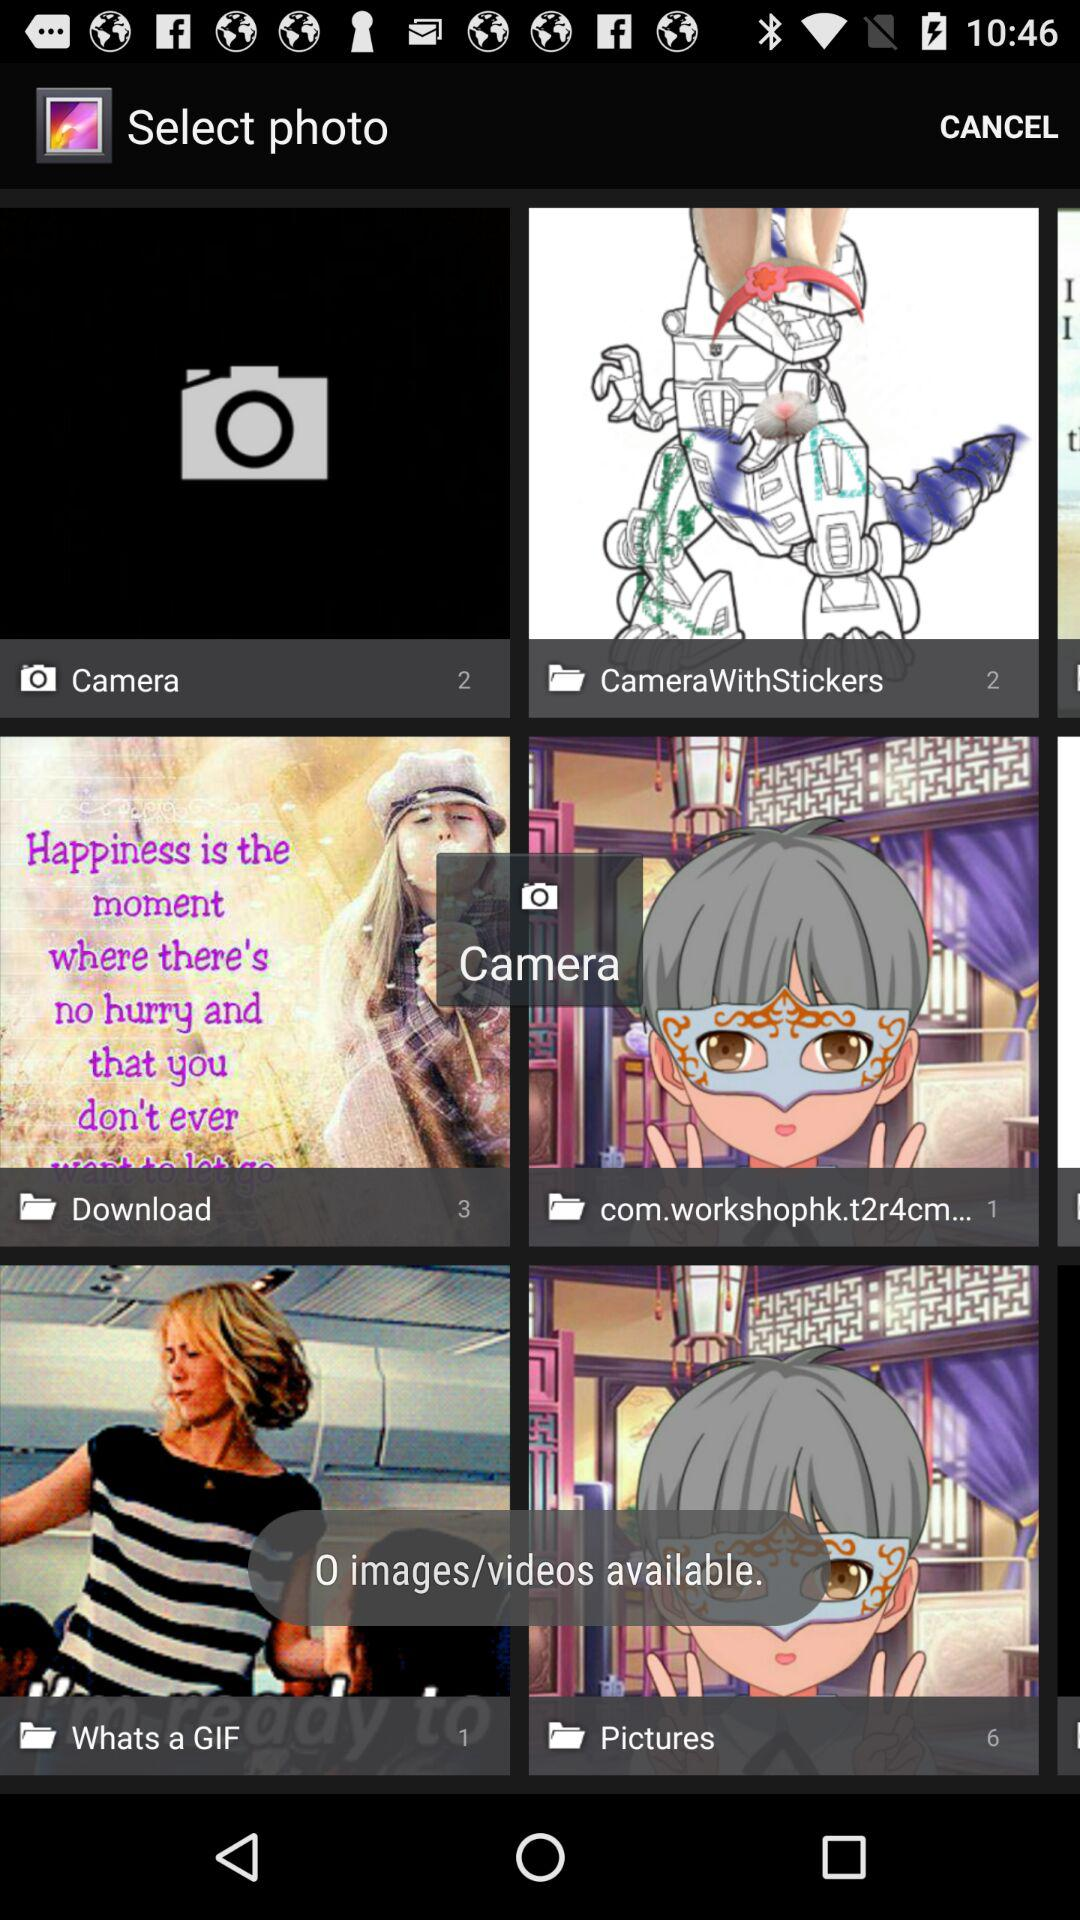What is the number of files in "Pictures"? The number of files in "Pictures" is 6. 